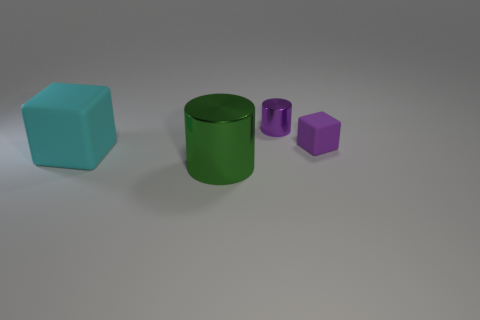Add 2 tiny rubber objects. How many objects exist? 6 Subtract 2 cylinders. How many cylinders are left? 0 Subtract all purple blocks. How many blocks are left? 1 Subtract 0 brown cylinders. How many objects are left? 4 Subtract all blue cubes. Subtract all purple cylinders. How many cubes are left? 2 Subtract all tiny cylinders. Subtract all cyan metallic balls. How many objects are left? 3 Add 3 big metal cylinders. How many big metal cylinders are left? 4 Add 2 yellow matte objects. How many yellow matte objects exist? 2 